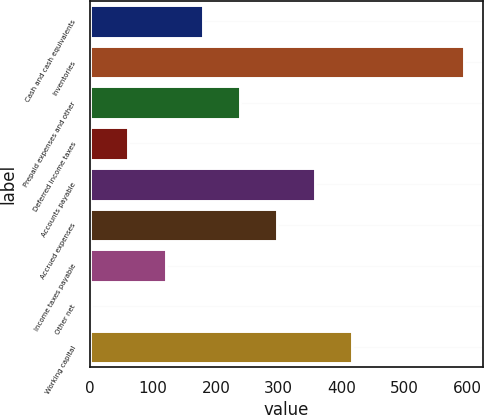Convert chart. <chart><loc_0><loc_0><loc_500><loc_500><bar_chart><fcel>Cash and cash equivalents<fcel>Inventories<fcel>Prepaid expenses and other<fcel>Deferred income taxes<fcel>Accounts payable<fcel>Accrued expenses<fcel>Income taxes payable<fcel>Other net<fcel>Working capital<nl><fcel>179.24<fcel>594.9<fcel>238.62<fcel>60.48<fcel>357.38<fcel>298<fcel>119.86<fcel>1.1<fcel>416.76<nl></chart> 